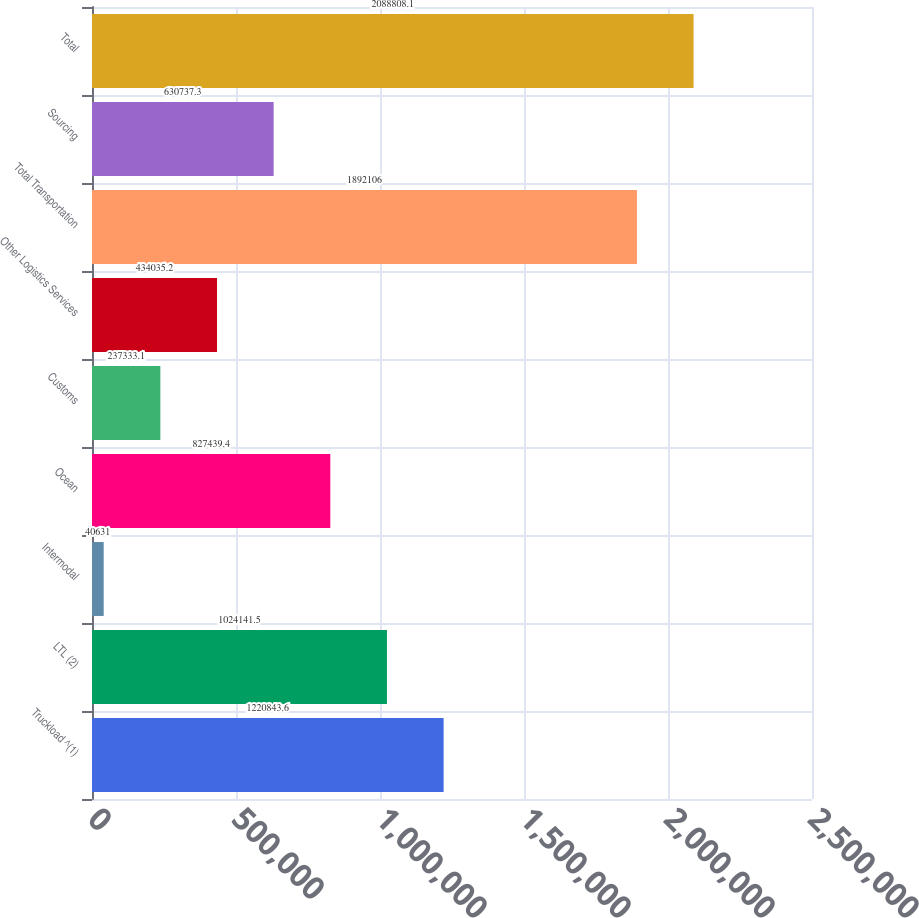Convert chart to OTSL. <chart><loc_0><loc_0><loc_500><loc_500><bar_chart><fcel>Truckload ^(1)<fcel>LTL (2)<fcel>Intermodal<fcel>Ocean<fcel>Customs<fcel>Other Logistics Services<fcel>Total Transportation<fcel>Sourcing<fcel>Total<nl><fcel>1.22084e+06<fcel>1.02414e+06<fcel>40631<fcel>827439<fcel>237333<fcel>434035<fcel>1.89211e+06<fcel>630737<fcel>2.08881e+06<nl></chart> 